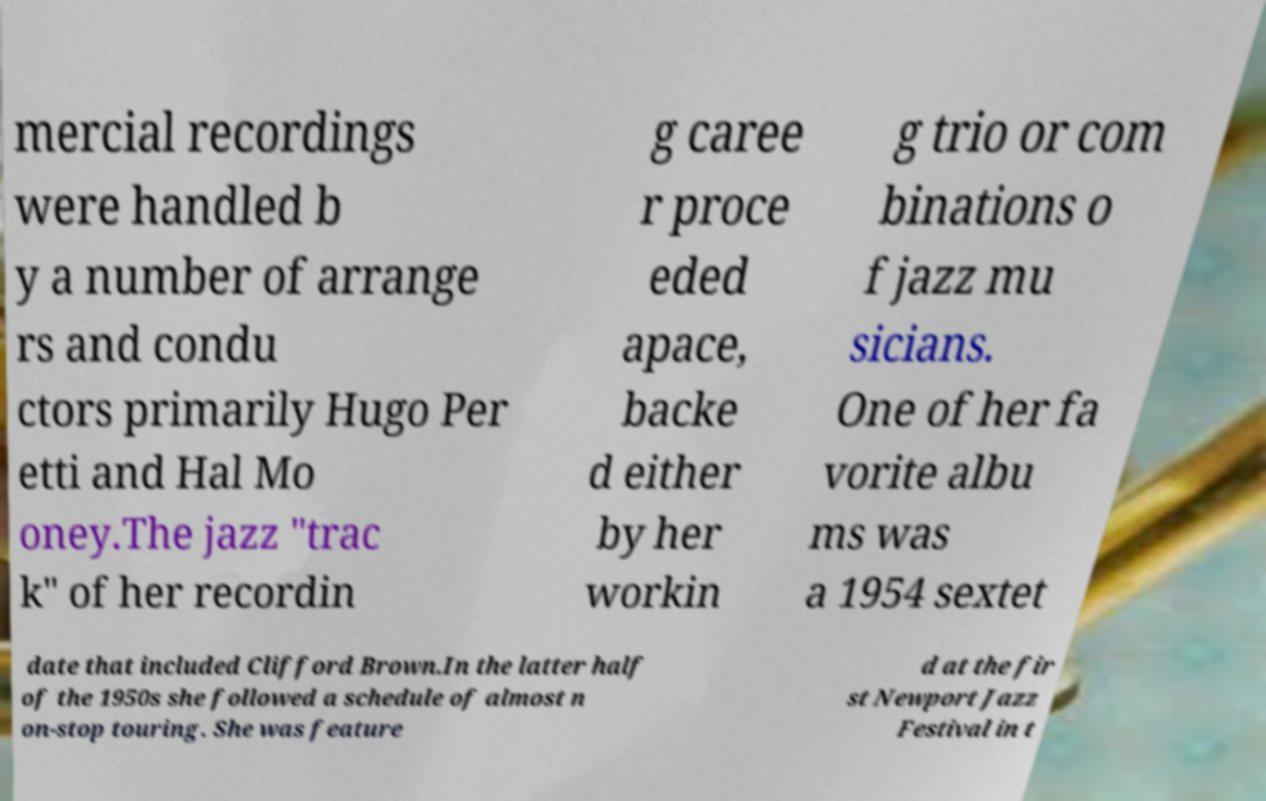Could you assist in decoding the text presented in this image and type it out clearly? mercial recordings were handled b y a number of arrange rs and condu ctors primarily Hugo Per etti and Hal Mo oney.The jazz "trac k" of her recordin g caree r proce eded apace, backe d either by her workin g trio or com binations o f jazz mu sicians. One of her fa vorite albu ms was a 1954 sextet date that included Clifford Brown.In the latter half of the 1950s she followed a schedule of almost n on-stop touring. She was feature d at the fir st Newport Jazz Festival in t 